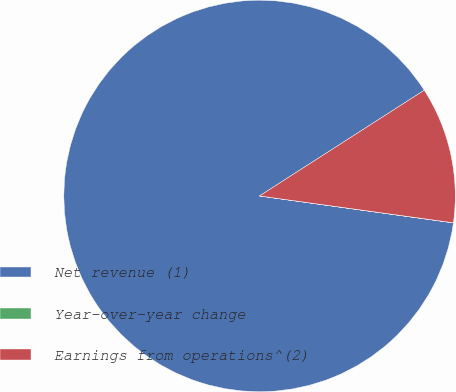<chart> <loc_0><loc_0><loc_500><loc_500><pie_chart><fcel>Net revenue (1)<fcel>Year-over-year change<fcel>Earnings from operations^(2)<nl><fcel>88.72%<fcel>0.01%<fcel>11.27%<nl></chart> 